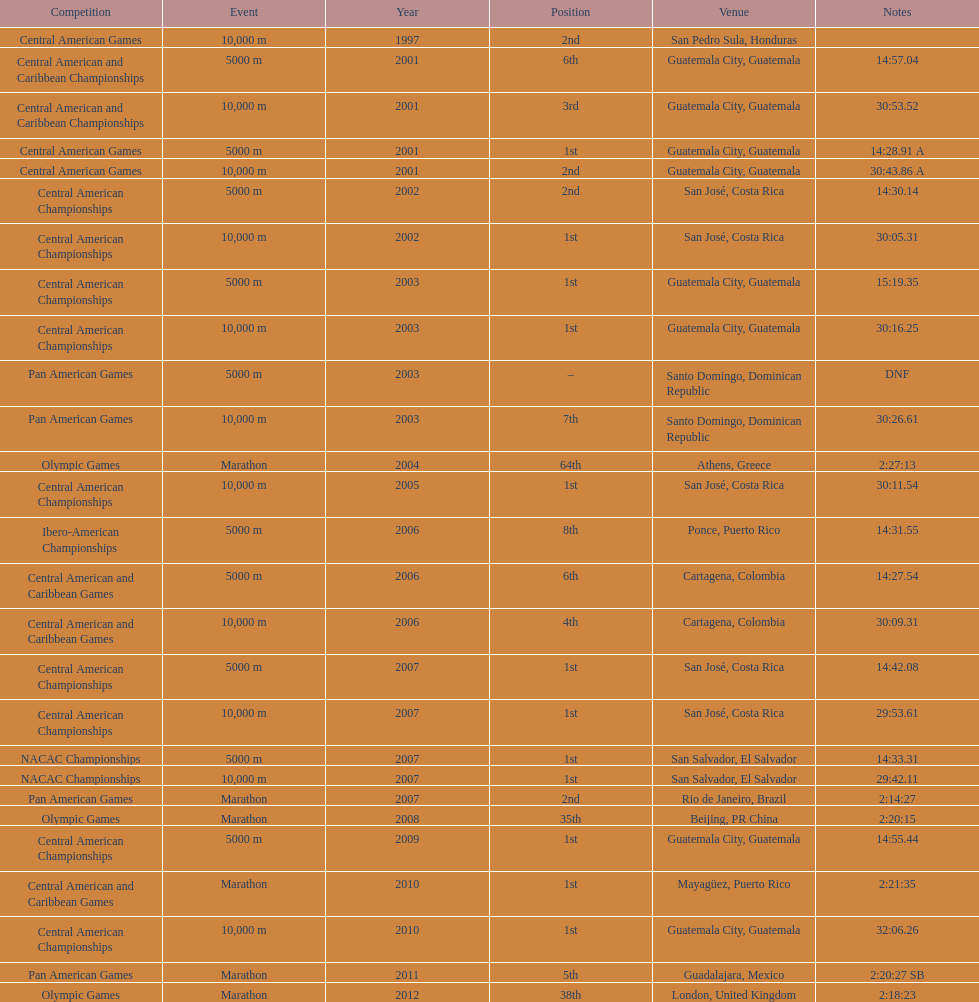What competition did this competitor compete at after participating in the central american games in 2001? Central American Championships. 